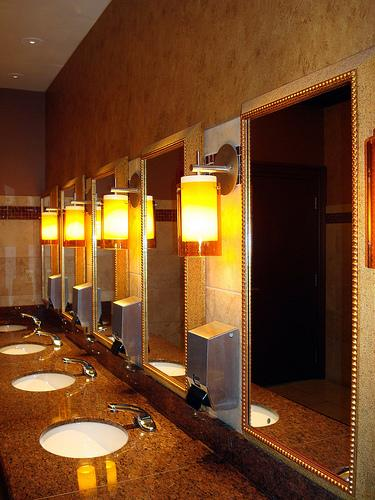What type of analysis task would this image be best suited for, and why? This image is best suited for an object detection task, as there are multiple objects and their positions and sizes are well-defined. What is the main purpose of this room? The main purpose of this room is to serve as a bathroom. How many lights can be seen in the image and where are they located? There are multiple light fixtures on the wall and two on the ceiling. What type of faucets are installed in the sinks? Silver automatic faucets are installed in the sinks. What is the material of the counter and how does it interact with the light? The material of the counter reflects light, creating a reflection of the light fixtures. List all objects present in the image. Sinks, counter, faucet, mirror, door, tiles, light fixture, soap dispenser, reflection, light, framed mirror, bathroom. Identify and describe the type of sinks present in the image. There are four sinks in the bathroom, numbered one to four, each installed with a silver automatic faucet. What elements in the image help suggest that the door is currently closed? The brown door reflected in the mirror appears closed, without any visible gaps. How would you describe the interior design and the general atmosphere of the room? The interior design appears clean and functional, featuring wall-mounted light fixtures, mirrors, sinks, and automatic soap dispensers. Count the number of soap dispensers and describe their locations. There are multiple soap dispensers on the wall near the sinks, and one between mirrors. 